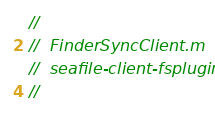<code> <loc_0><loc_0><loc_500><loc_500><_ObjectiveC_>//
//  FinderSyncClient.m
//  seafile-client-fsplugin
//</code> 